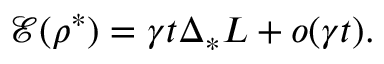Convert formula to latex. <formula><loc_0><loc_0><loc_500><loc_500>\ m a t h s c r { E } ( \rho ^ { * } ) = \gamma t \Delta _ { * } L + o ( \gamma t ) .</formula> 